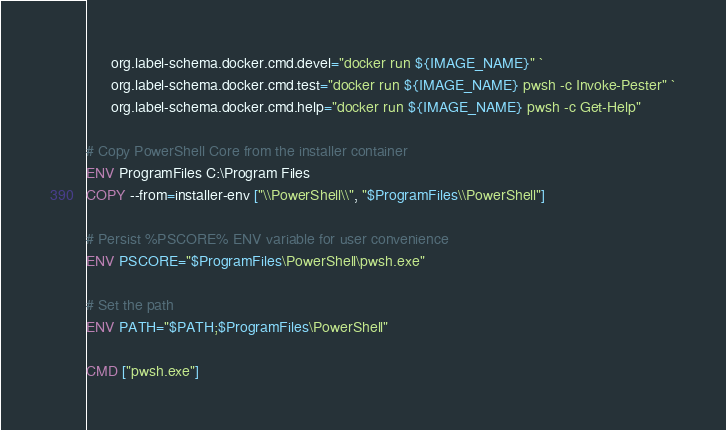Convert code to text. <code><loc_0><loc_0><loc_500><loc_500><_Dockerfile_>      org.label-schema.docker.cmd.devel="docker run ${IMAGE_NAME}" `
      org.label-schema.docker.cmd.test="docker run ${IMAGE_NAME} pwsh -c Invoke-Pester" `
      org.label-schema.docker.cmd.help="docker run ${IMAGE_NAME} pwsh -c Get-Help"

# Copy PowerShell Core from the installer container
ENV ProgramFiles C:\Program Files
COPY --from=installer-env ["\\PowerShell\\", "$ProgramFiles\\PowerShell"]

# Persist %PSCORE% ENV variable for user convenience
ENV PSCORE="$ProgramFiles\PowerShell\pwsh.exe"

# Set the path
ENV PATH="$PATH;$ProgramFiles\PowerShell"

CMD ["pwsh.exe"]
</code> 